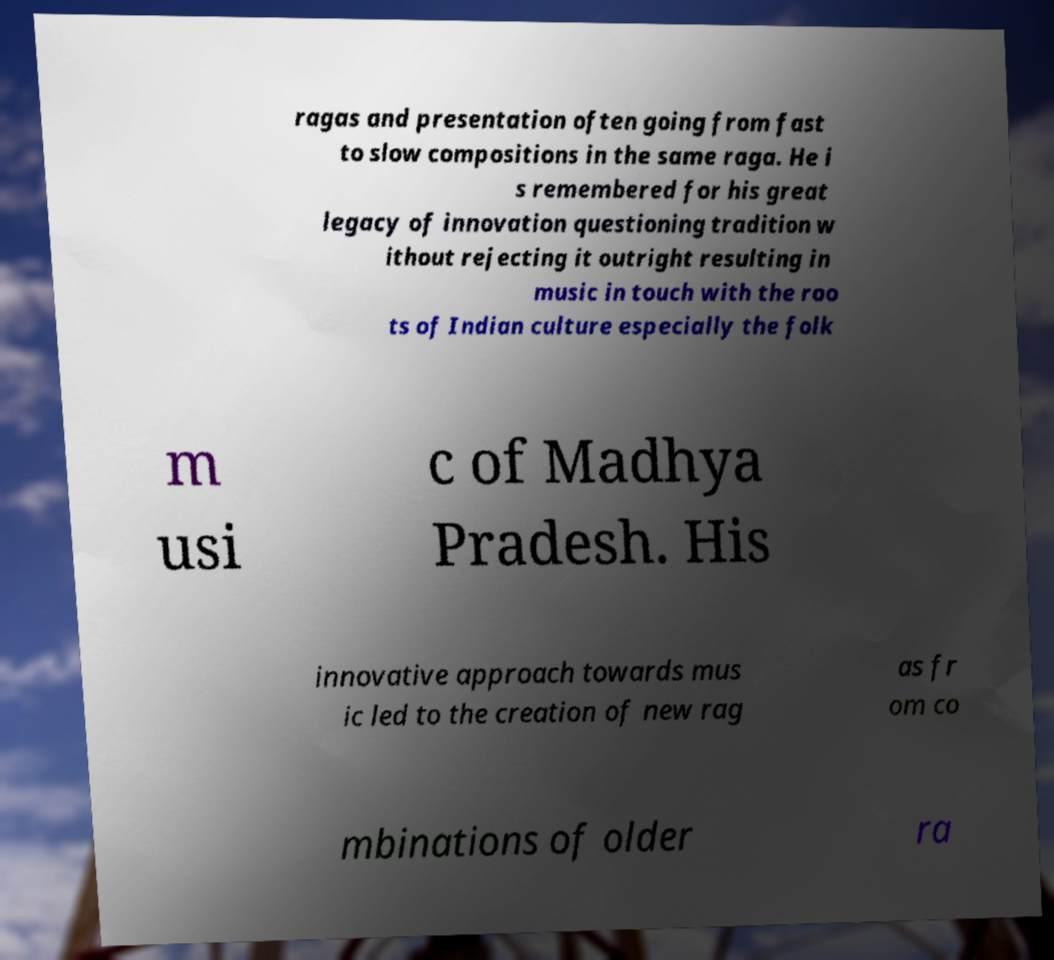There's text embedded in this image that I need extracted. Can you transcribe it verbatim? ragas and presentation often going from fast to slow compositions in the same raga. He i s remembered for his great legacy of innovation questioning tradition w ithout rejecting it outright resulting in music in touch with the roo ts of Indian culture especially the folk m usi c of Madhya Pradesh. His innovative approach towards mus ic led to the creation of new rag as fr om co mbinations of older ra 